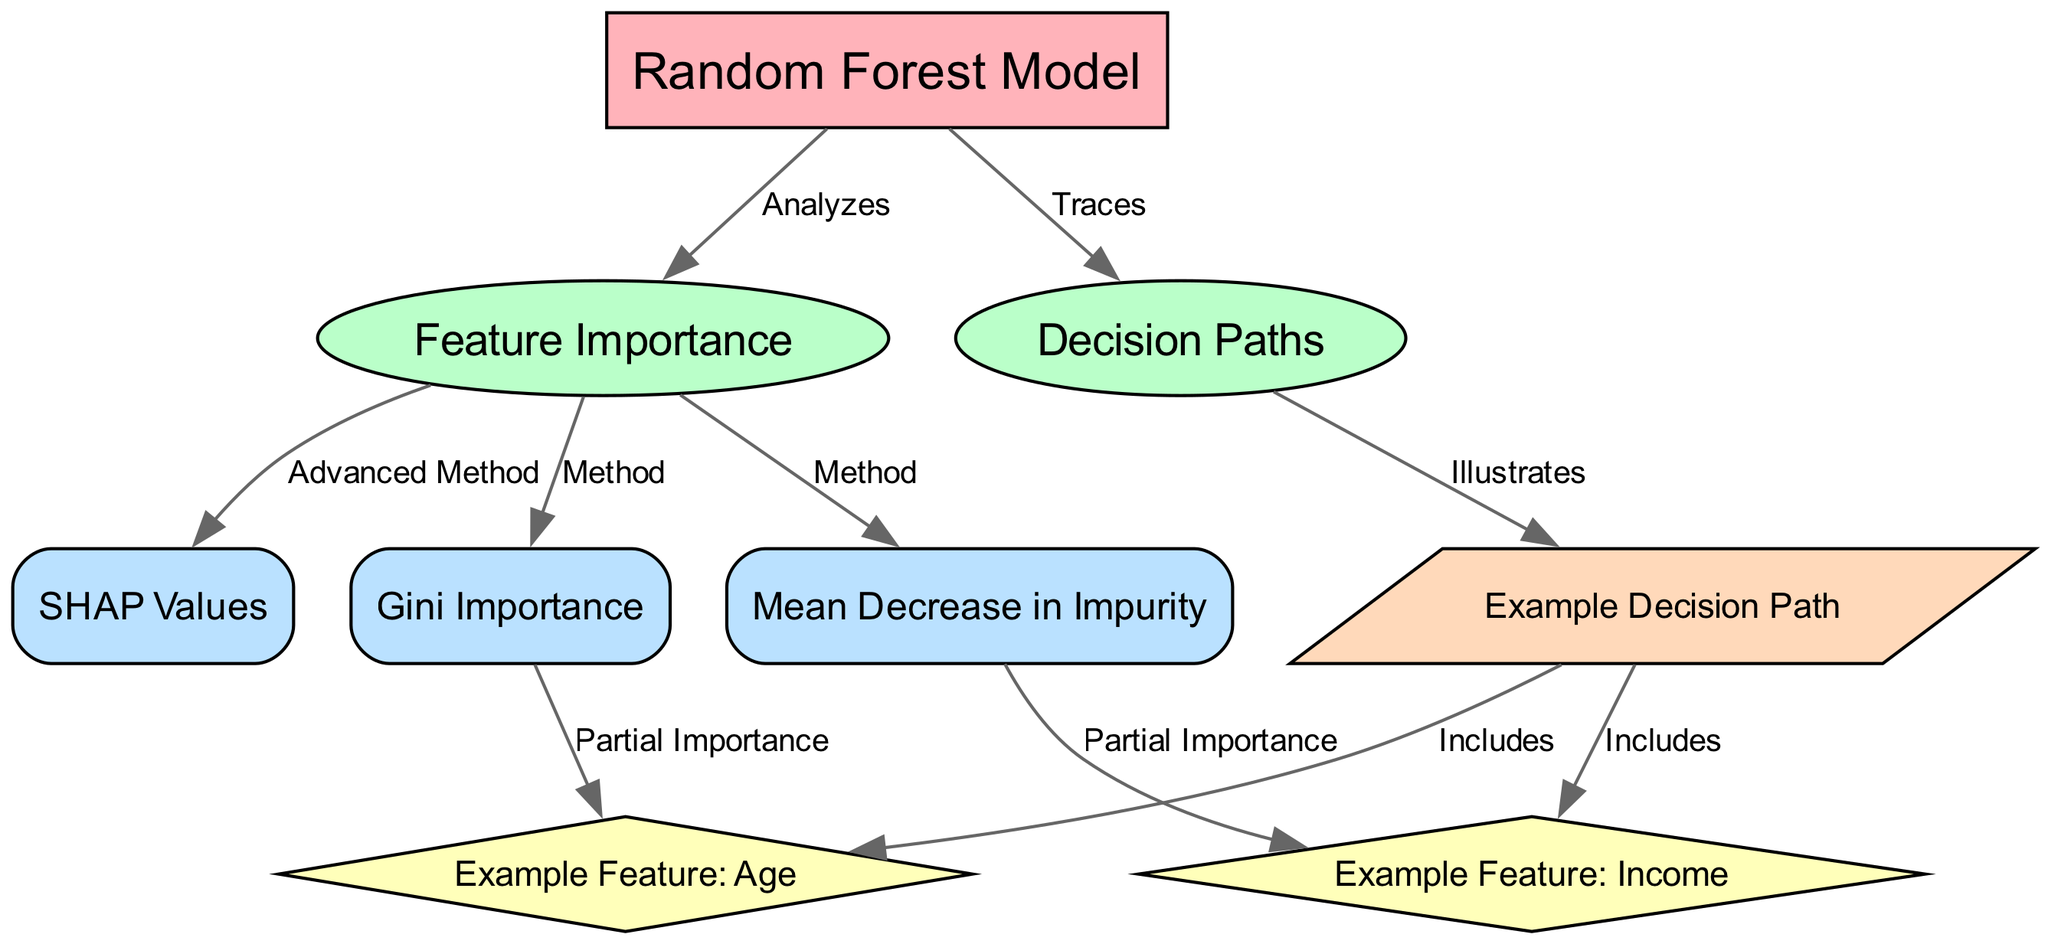What is the central node in the diagram? The central node is labeled "Random Forest Model," which is identified as the primary focus of the diagram.
Answer: Random Forest Model How many major nodes are present in the diagram? There are two major nodes, "Feature Importance" and "Decision Paths," connected to the central node, indicating the diagram's main topics.
Answer: 2 What method of feature importance is indicated as "Advanced Method"? The method labeled as "Advanced Method" is "SHAP Values," which is detailed in the diagram.
Answer: SHAP Values Which example feature is connected to Gini Importance? The example feature "Age" is linked to the Gini Importance node, suggesting its relevance in calculating feature importance.
Answer: Age What is illustrated by an example decision path in the diagram? The example decision path includes both "Age" and "Income," showing how these features are involved in decision-making within the Random Forest.
Answer: Age and Income What relationship exists between "Feature Importance" and "Decision Paths"? The relationship is that "Feature Importance" is analyzed to contribute to the understanding of "Decision Paths," highlighting how feature contributions affect predictions.
Answer: Traces Which node is a detail method for "Feature Importance"? The node "Mean Decrease in Impurity" is categorized as a detail method related to Feature Importance, reflecting a specific approach to measurement.
Answer: Mean Decrease in Impurity How many edges connect to the "Feature Importance" node? There are three edges connecting to the "Feature Importance" node, each showing a different method related to feature evaluation.
Answer: 3 What color represents the detail nodes in the diagram? The detail nodes are represented in a light blue color (#BAE1FF), distinguishing them from other types of nodes.
Answer: Light blue 